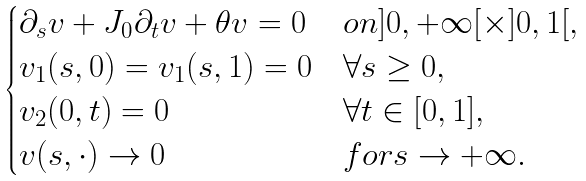<formula> <loc_0><loc_0><loc_500><loc_500>\begin{cases} \partial _ { s } v + J _ { 0 } \partial _ { t } v + \theta v = 0 & o n ] 0 , + \infty [ \times ] 0 , 1 [ , \\ v _ { 1 } ( s , 0 ) = v _ { 1 } ( s , 1 ) = 0 & \forall s \geq 0 , \\ v _ { 2 } ( 0 , t ) = 0 & \forall t \in [ 0 , 1 ] , \\ v ( s , \cdot ) \rightarrow 0 & f o r s \rightarrow + \infty . \end{cases}</formula> 